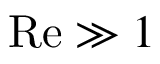Convert formula to latex. <formula><loc_0><loc_0><loc_500><loc_500>R e \gg 1</formula> 